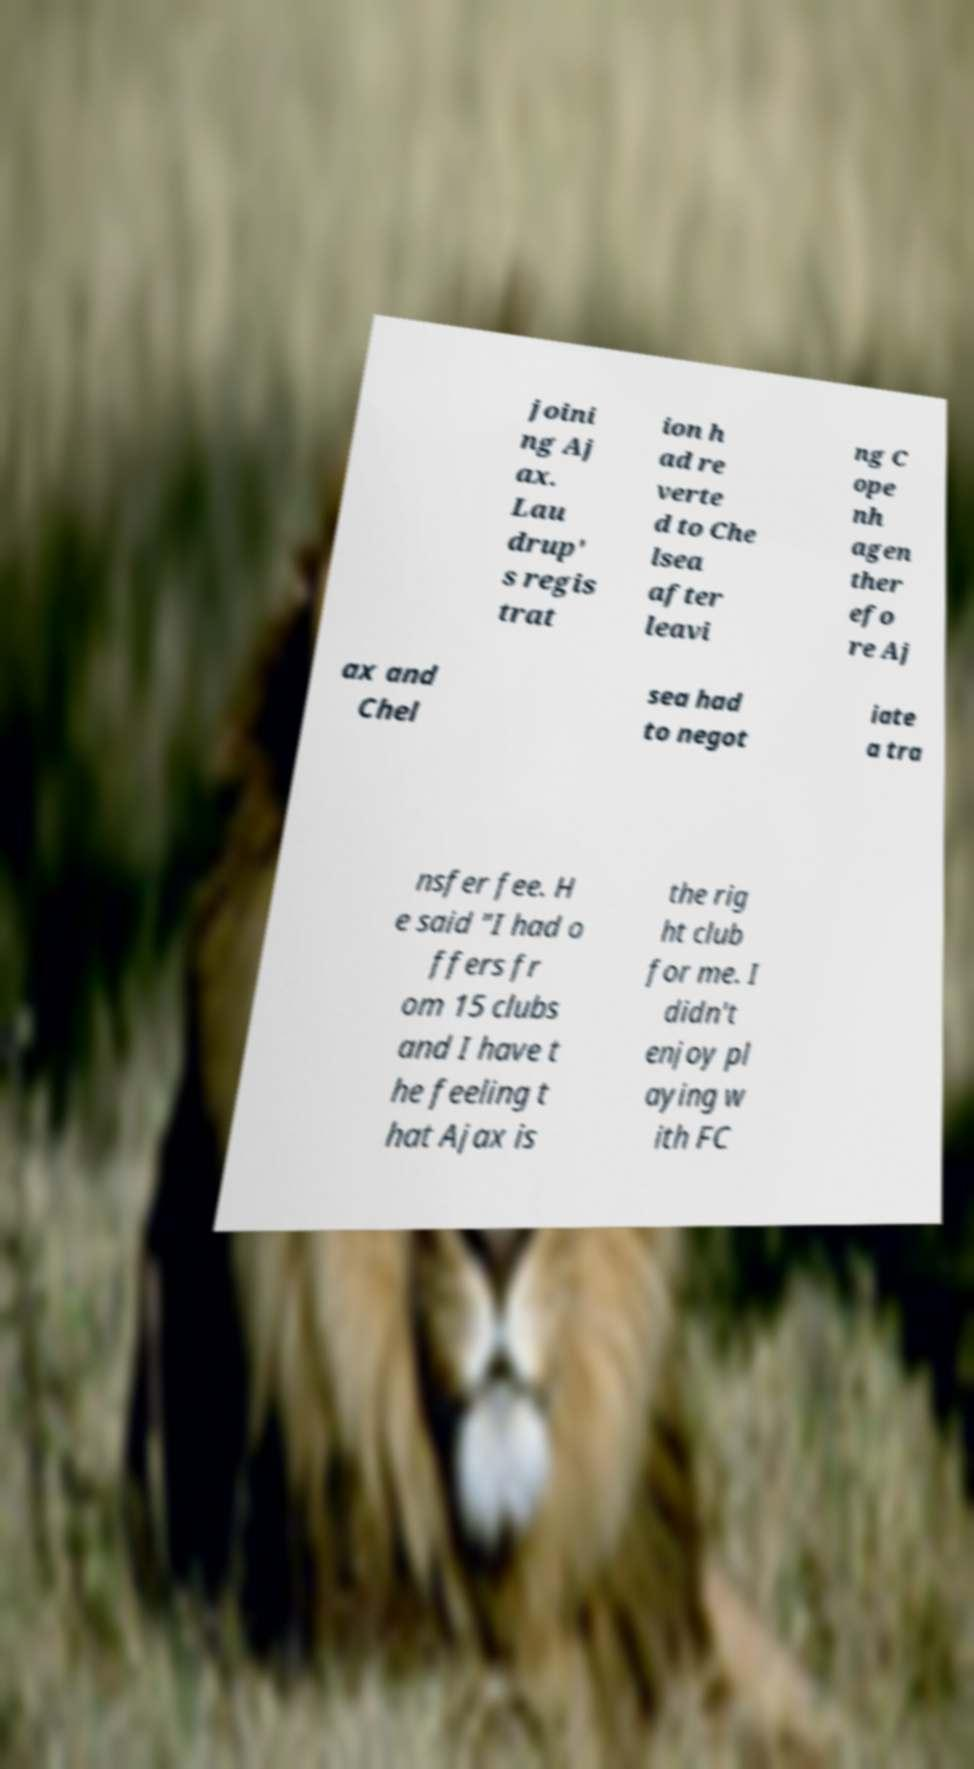What messages or text are displayed in this image? I need them in a readable, typed format. joini ng Aj ax. Lau drup' s regis trat ion h ad re verte d to Che lsea after leavi ng C ope nh agen ther efo re Aj ax and Chel sea had to negot iate a tra nsfer fee. H e said "I had o ffers fr om 15 clubs and I have t he feeling t hat Ajax is the rig ht club for me. I didn't enjoy pl aying w ith FC 